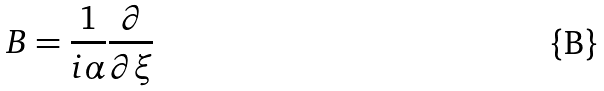Convert formula to latex. <formula><loc_0><loc_0><loc_500><loc_500>B = \frac { 1 } { i \alpha } \frac { \partial } { \partial \xi }</formula> 